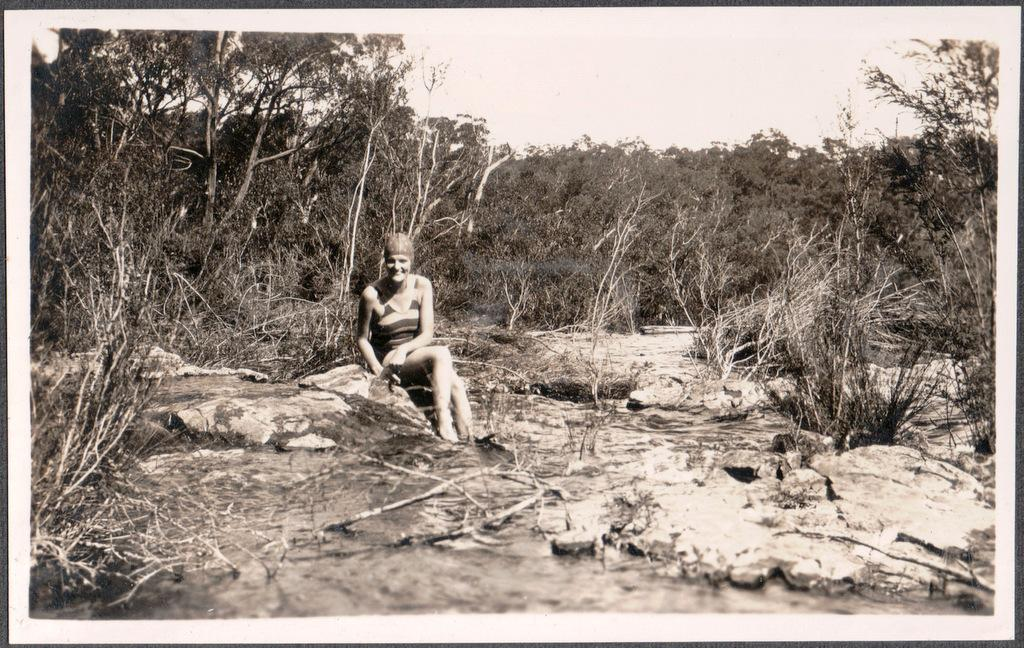What is the color scheme of the image? The image is black and white. What is the woman in the image doing? The woman is sitting on the rocks in the image. What can be heard in the image? There is running water in the image, which suggests the sound of water. What type of vegetation is present in the image? There are trees in the image. What is visible in the background of the image? The sky is visible in the image. What color are the woman's eyes in the image? The image is black and white, so it is not possible to determine the color of the woman's eyes. What show is the woman watching in the image? There is no indication of a show or any electronic device in the image. 